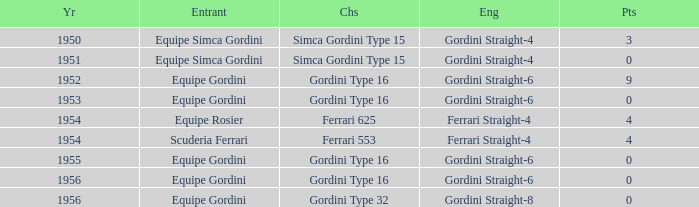What engine was used by Equipe Simca Gordini before 1956 with less than 4 points? Gordini Straight-4, Gordini Straight-4. Can you parse all the data within this table? {'header': ['Yr', 'Entrant', 'Chs', 'Eng', 'Pts'], 'rows': [['1950', 'Equipe Simca Gordini', 'Simca Gordini Type 15', 'Gordini Straight-4', '3'], ['1951', 'Equipe Simca Gordini', 'Simca Gordini Type 15', 'Gordini Straight-4', '0'], ['1952', 'Equipe Gordini', 'Gordini Type 16', 'Gordini Straight-6', '9'], ['1953', 'Equipe Gordini', 'Gordini Type 16', 'Gordini Straight-6', '0'], ['1954', 'Equipe Rosier', 'Ferrari 625', 'Ferrari Straight-4', '4'], ['1954', 'Scuderia Ferrari', 'Ferrari 553', 'Ferrari Straight-4', '4'], ['1955', 'Equipe Gordini', 'Gordini Type 16', 'Gordini Straight-6', '0'], ['1956', 'Equipe Gordini', 'Gordini Type 16', 'Gordini Straight-6', '0'], ['1956', 'Equipe Gordini', 'Gordini Type 32', 'Gordini Straight-8', '0']]} 